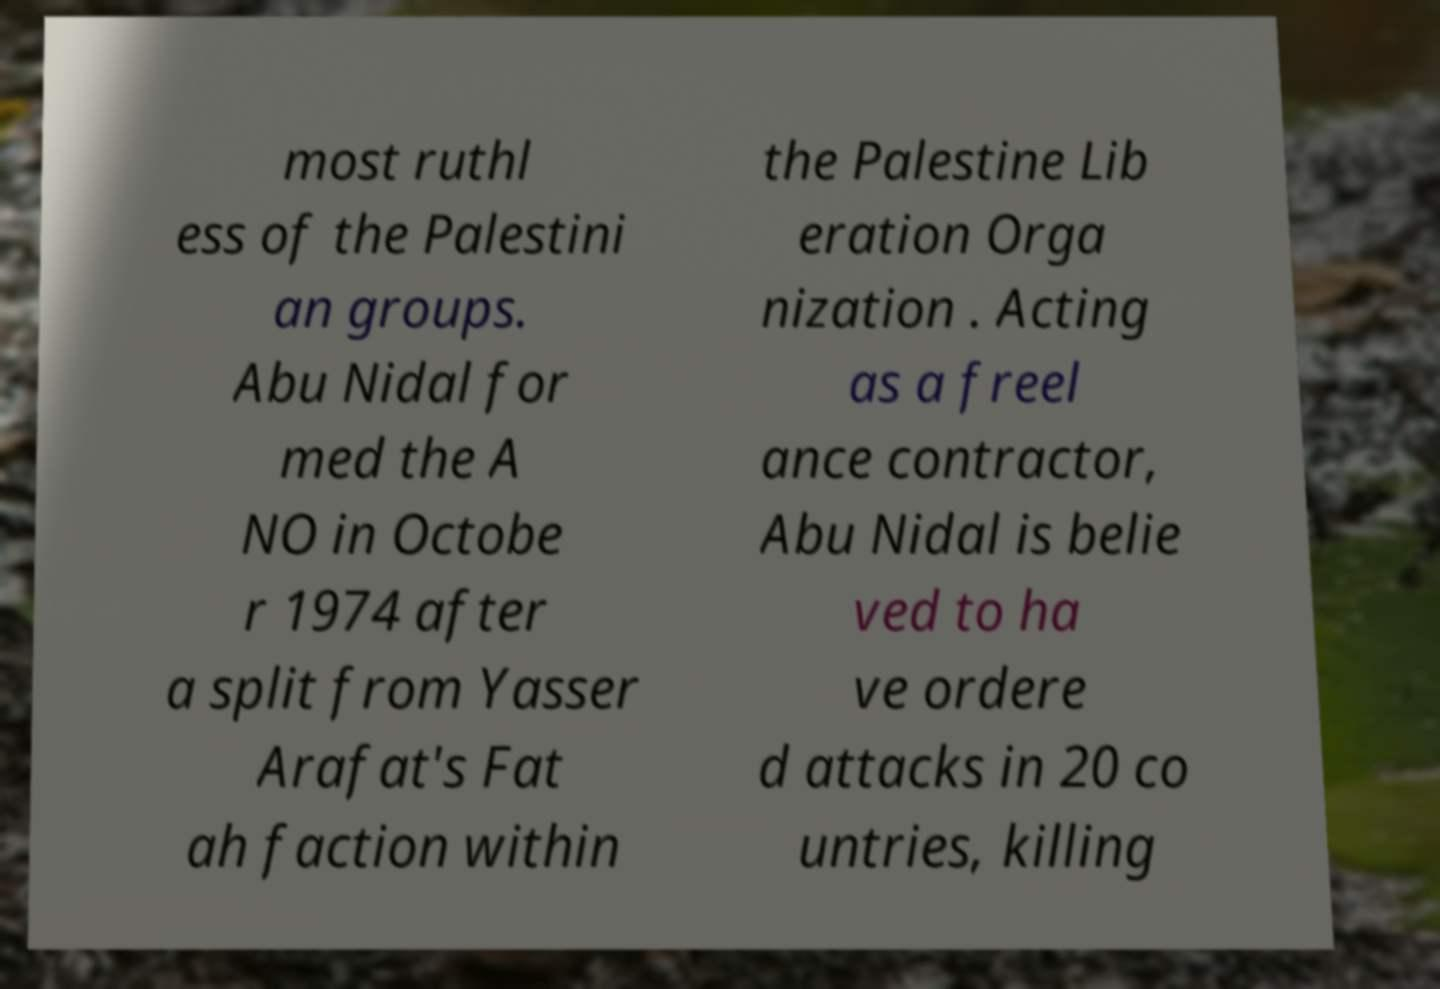Please identify and transcribe the text found in this image. most ruthl ess of the Palestini an groups. Abu Nidal for med the A NO in Octobe r 1974 after a split from Yasser Arafat's Fat ah faction within the Palestine Lib eration Orga nization . Acting as a freel ance contractor, Abu Nidal is belie ved to ha ve ordere d attacks in 20 co untries, killing 